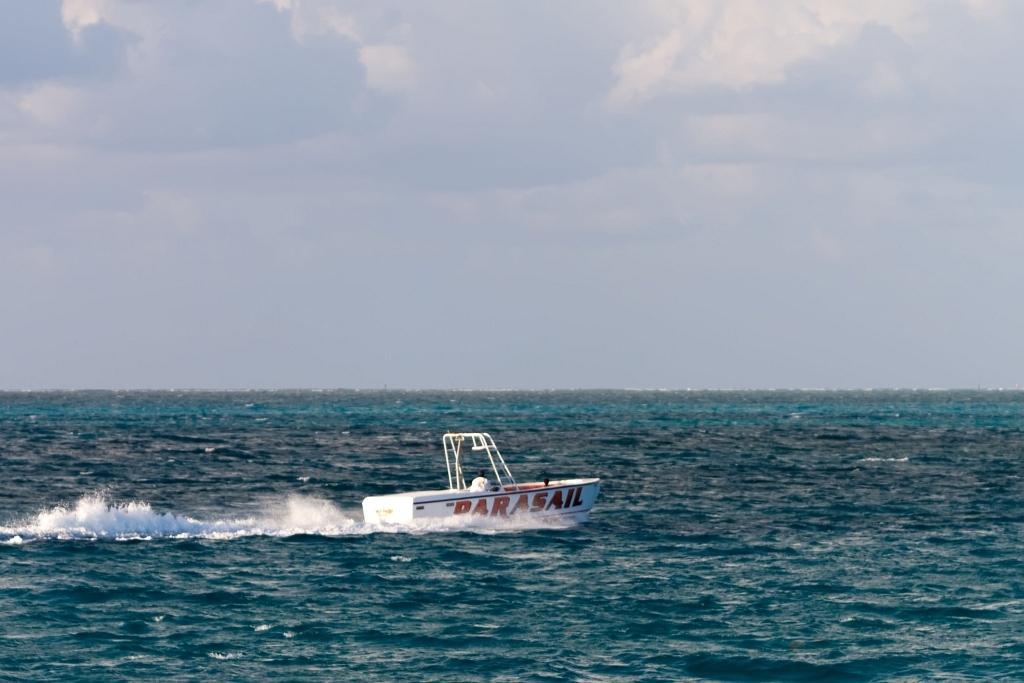In one or two sentences, can you explain what this image depicts? In the center of the image, we can see some people in the boat and at the bottom, there is water and at the top, there are clouds in the sky. 